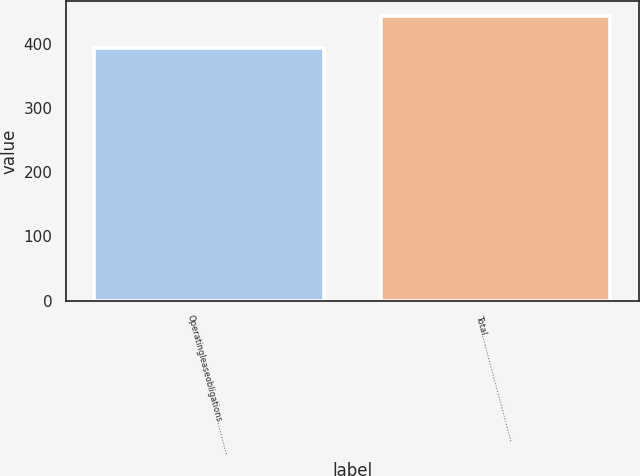Convert chart to OTSL. <chart><loc_0><loc_0><loc_500><loc_500><bar_chart><fcel>Operatingleaseobligations…………<fcel>Total…………………………………<nl><fcel>393.9<fcel>443.9<nl></chart> 